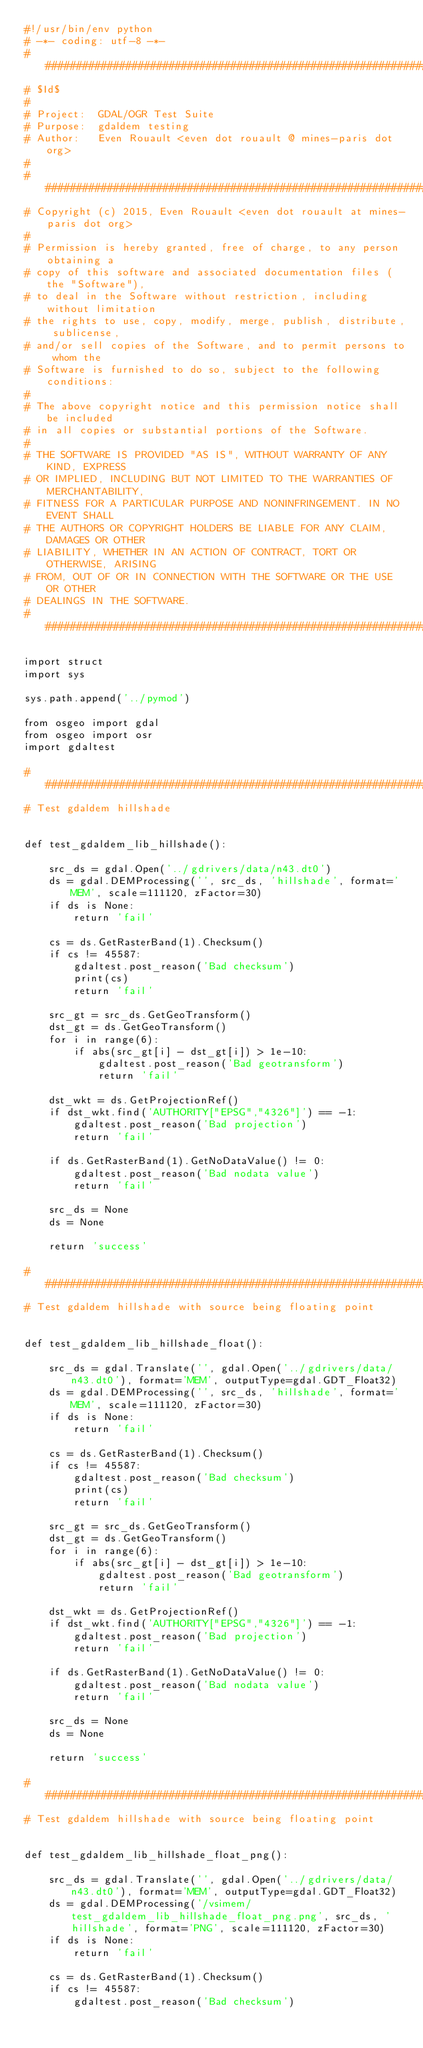Convert code to text. <code><loc_0><loc_0><loc_500><loc_500><_Python_>#!/usr/bin/env python
# -*- coding: utf-8 -*-
###############################################################################
# $Id$
#
# Project:  GDAL/OGR Test Suite
# Purpose:  gdaldem testing
# Author:   Even Rouault <even dot rouault @ mines-paris dot org>
#
###############################################################################
# Copyright (c) 2015, Even Rouault <even dot rouault at mines-paris dot org>
#
# Permission is hereby granted, free of charge, to any person obtaining a
# copy of this software and associated documentation files (the "Software"),
# to deal in the Software without restriction, including without limitation
# the rights to use, copy, modify, merge, publish, distribute, sublicense,
# and/or sell copies of the Software, and to permit persons to whom the
# Software is furnished to do so, subject to the following conditions:
#
# The above copyright notice and this permission notice shall be included
# in all copies or substantial portions of the Software.
#
# THE SOFTWARE IS PROVIDED "AS IS", WITHOUT WARRANTY OF ANY KIND, EXPRESS
# OR IMPLIED, INCLUDING BUT NOT LIMITED TO THE WARRANTIES OF MERCHANTABILITY,
# FITNESS FOR A PARTICULAR PURPOSE AND NONINFRINGEMENT. IN NO EVENT SHALL
# THE AUTHORS OR COPYRIGHT HOLDERS BE LIABLE FOR ANY CLAIM, DAMAGES OR OTHER
# LIABILITY, WHETHER IN AN ACTION OF CONTRACT, TORT OR OTHERWISE, ARISING
# FROM, OUT OF OR IN CONNECTION WITH THE SOFTWARE OR THE USE OR OTHER
# DEALINGS IN THE SOFTWARE.
###############################################################################

import struct
import sys

sys.path.append('../pymod')

from osgeo import gdal
from osgeo import osr
import gdaltest

###############################################################################
# Test gdaldem hillshade


def test_gdaldem_lib_hillshade():

    src_ds = gdal.Open('../gdrivers/data/n43.dt0')
    ds = gdal.DEMProcessing('', src_ds, 'hillshade', format='MEM', scale=111120, zFactor=30)
    if ds is None:
        return 'fail'

    cs = ds.GetRasterBand(1).Checksum()
    if cs != 45587:
        gdaltest.post_reason('Bad checksum')
        print(cs)
        return 'fail'

    src_gt = src_ds.GetGeoTransform()
    dst_gt = ds.GetGeoTransform()
    for i in range(6):
        if abs(src_gt[i] - dst_gt[i]) > 1e-10:
            gdaltest.post_reason('Bad geotransform')
            return 'fail'

    dst_wkt = ds.GetProjectionRef()
    if dst_wkt.find('AUTHORITY["EPSG","4326"]') == -1:
        gdaltest.post_reason('Bad projection')
        return 'fail'

    if ds.GetRasterBand(1).GetNoDataValue() != 0:
        gdaltest.post_reason('Bad nodata value')
        return 'fail'

    src_ds = None
    ds = None

    return 'success'

###############################################################################
# Test gdaldem hillshade with source being floating point


def test_gdaldem_lib_hillshade_float():

    src_ds = gdal.Translate('', gdal.Open('../gdrivers/data/n43.dt0'), format='MEM', outputType=gdal.GDT_Float32)
    ds = gdal.DEMProcessing('', src_ds, 'hillshade', format='MEM', scale=111120, zFactor=30)
    if ds is None:
        return 'fail'

    cs = ds.GetRasterBand(1).Checksum()
    if cs != 45587:
        gdaltest.post_reason('Bad checksum')
        print(cs)
        return 'fail'

    src_gt = src_ds.GetGeoTransform()
    dst_gt = ds.GetGeoTransform()
    for i in range(6):
        if abs(src_gt[i] - dst_gt[i]) > 1e-10:
            gdaltest.post_reason('Bad geotransform')
            return 'fail'

    dst_wkt = ds.GetProjectionRef()
    if dst_wkt.find('AUTHORITY["EPSG","4326"]') == -1:
        gdaltest.post_reason('Bad projection')
        return 'fail'

    if ds.GetRasterBand(1).GetNoDataValue() != 0:
        gdaltest.post_reason('Bad nodata value')
        return 'fail'

    src_ds = None
    ds = None

    return 'success'

###############################################################################
# Test gdaldem hillshade with source being floating point


def test_gdaldem_lib_hillshade_float_png():

    src_ds = gdal.Translate('', gdal.Open('../gdrivers/data/n43.dt0'), format='MEM', outputType=gdal.GDT_Float32)
    ds = gdal.DEMProcessing('/vsimem/test_gdaldem_lib_hillshade_float_png.png', src_ds, 'hillshade', format='PNG', scale=111120, zFactor=30)
    if ds is None:
        return 'fail'

    cs = ds.GetRasterBand(1).Checksum()
    if cs != 45587:
        gdaltest.post_reason('Bad checksum')</code> 